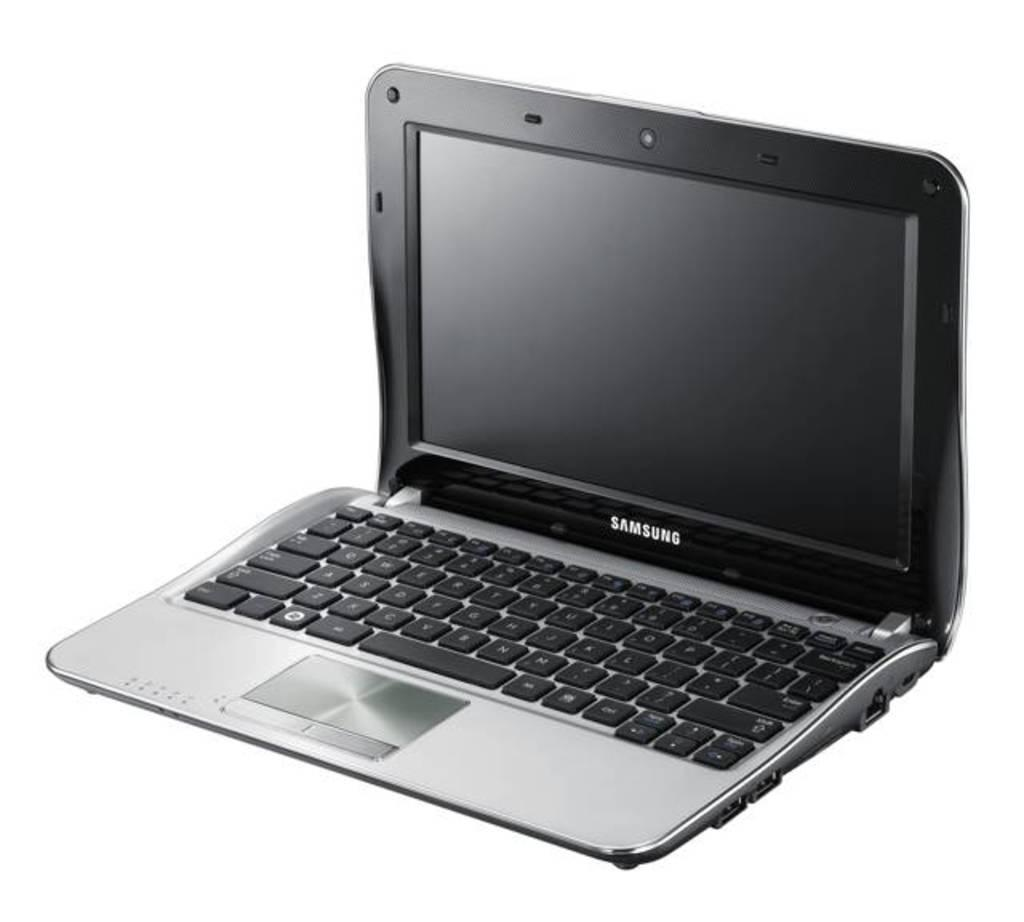Provide a one-sentence caption for the provided image. A Samsung laptop computer with silver and black coloring and a shiny touchpad. 